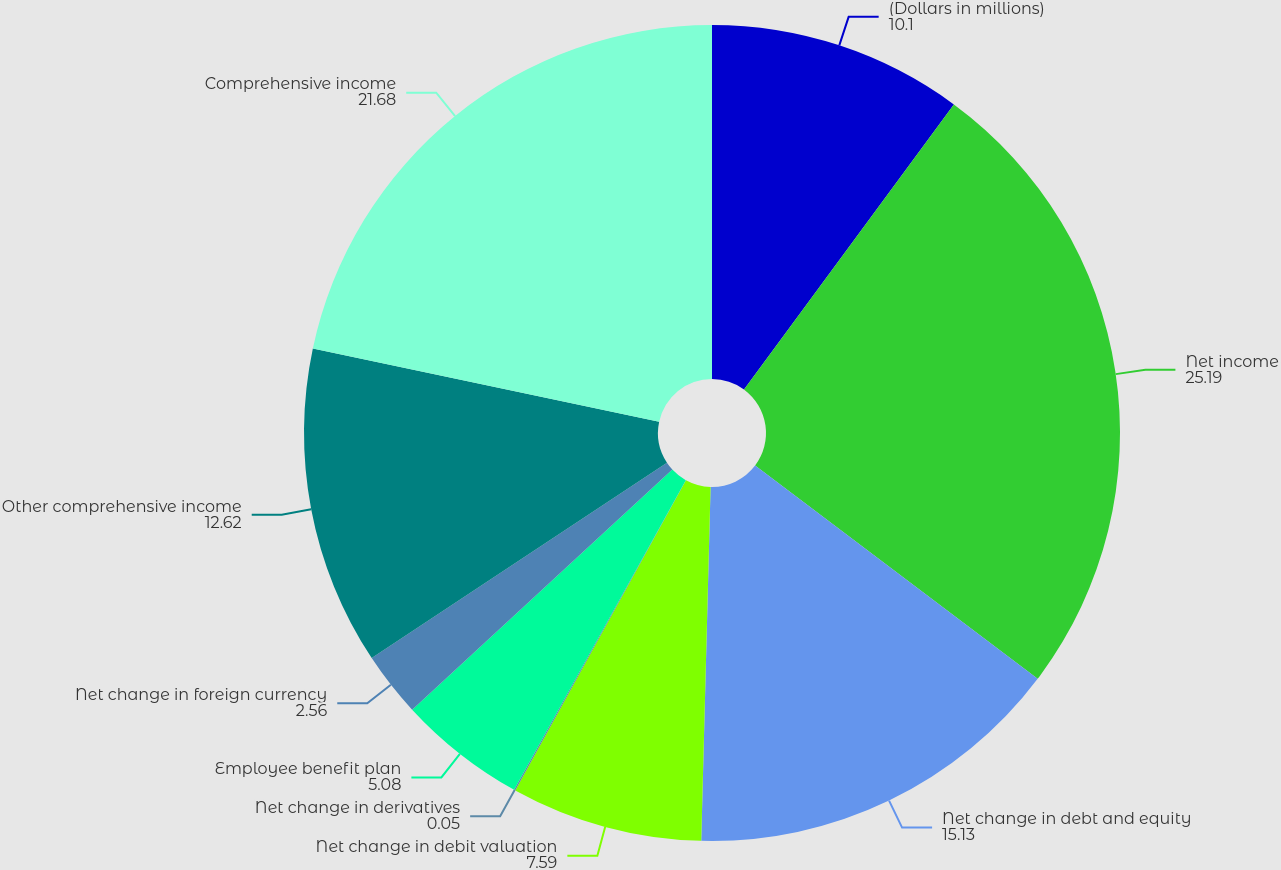<chart> <loc_0><loc_0><loc_500><loc_500><pie_chart><fcel>(Dollars in millions)<fcel>Net income<fcel>Net change in debt and equity<fcel>Net change in debit valuation<fcel>Net change in derivatives<fcel>Employee benefit plan<fcel>Net change in foreign currency<fcel>Other comprehensive income<fcel>Comprehensive income<nl><fcel>10.1%<fcel>25.19%<fcel>15.13%<fcel>7.59%<fcel>0.05%<fcel>5.08%<fcel>2.56%<fcel>12.62%<fcel>21.68%<nl></chart> 